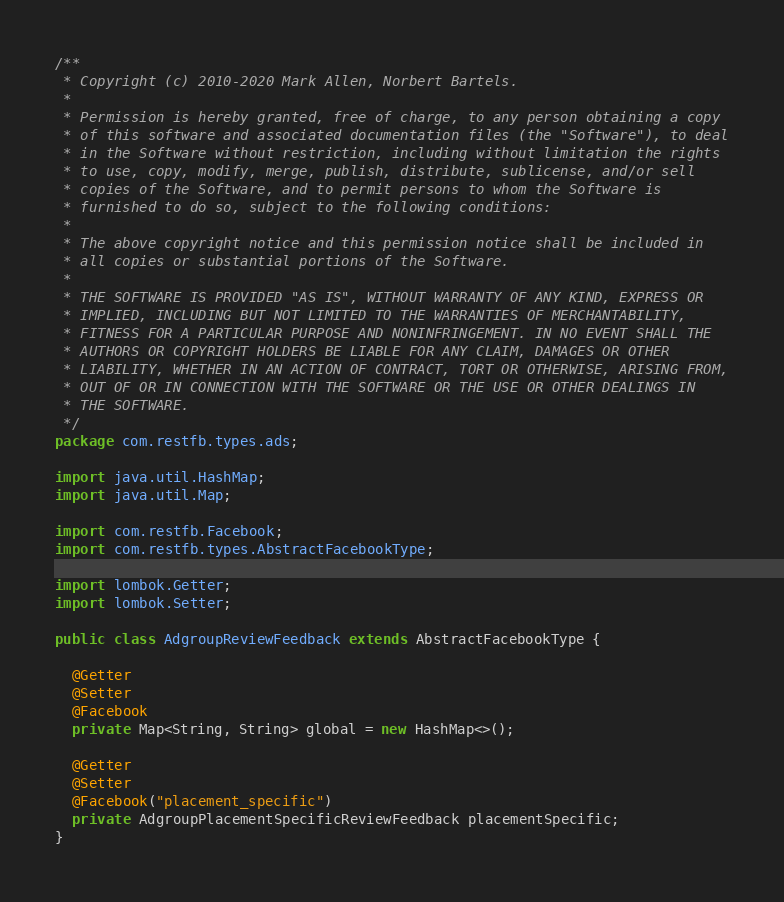<code> <loc_0><loc_0><loc_500><loc_500><_Java_>/**
 * Copyright (c) 2010-2020 Mark Allen, Norbert Bartels.
 *
 * Permission is hereby granted, free of charge, to any person obtaining a copy
 * of this software and associated documentation files (the "Software"), to deal
 * in the Software without restriction, including without limitation the rights
 * to use, copy, modify, merge, publish, distribute, sublicense, and/or sell
 * copies of the Software, and to permit persons to whom the Software is
 * furnished to do so, subject to the following conditions:
 *
 * The above copyright notice and this permission notice shall be included in
 * all copies or substantial portions of the Software.
 *
 * THE SOFTWARE IS PROVIDED "AS IS", WITHOUT WARRANTY OF ANY KIND, EXPRESS OR
 * IMPLIED, INCLUDING BUT NOT LIMITED TO THE WARRANTIES OF MERCHANTABILITY,
 * FITNESS FOR A PARTICULAR PURPOSE AND NONINFRINGEMENT. IN NO EVENT SHALL THE
 * AUTHORS OR COPYRIGHT HOLDERS BE LIABLE FOR ANY CLAIM, DAMAGES OR OTHER
 * LIABILITY, WHETHER IN AN ACTION OF CONTRACT, TORT OR OTHERWISE, ARISING FROM,
 * OUT OF OR IN CONNECTION WITH THE SOFTWARE OR THE USE OR OTHER DEALINGS IN
 * THE SOFTWARE.
 */
package com.restfb.types.ads;

import java.util.HashMap;
import java.util.Map;

import com.restfb.Facebook;
import com.restfb.types.AbstractFacebookType;

import lombok.Getter;
import lombok.Setter;

public class AdgroupReviewFeedback extends AbstractFacebookType {

  @Getter
  @Setter
  @Facebook
  private Map<String, String> global = new HashMap<>();

  @Getter
  @Setter
  @Facebook("placement_specific")
  private AdgroupPlacementSpecificReviewFeedback placementSpecific;
}
</code> 